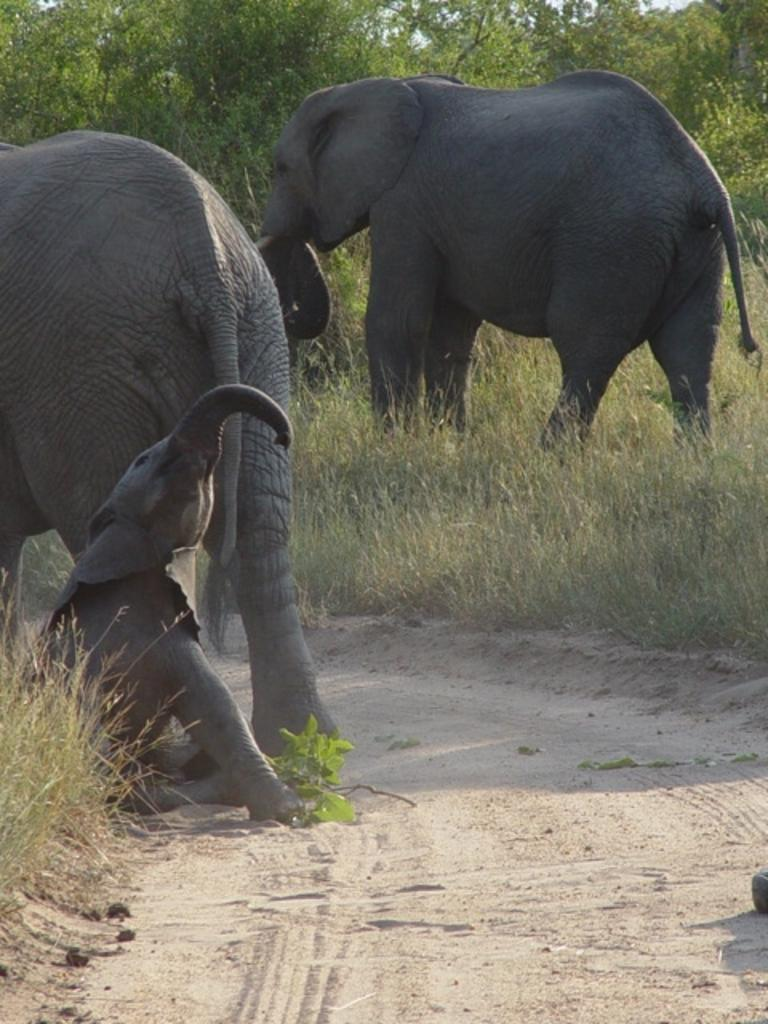What animals are present in the image? There are elephants in the image. What type of terrain are the elephants standing on? The elephants are on grass. What can be seen in the background of the image? There are trees visible at the top of the image. What type of soup is being served in the image? There is no soup present in the image; it features elephants on grass with trees in the background. 